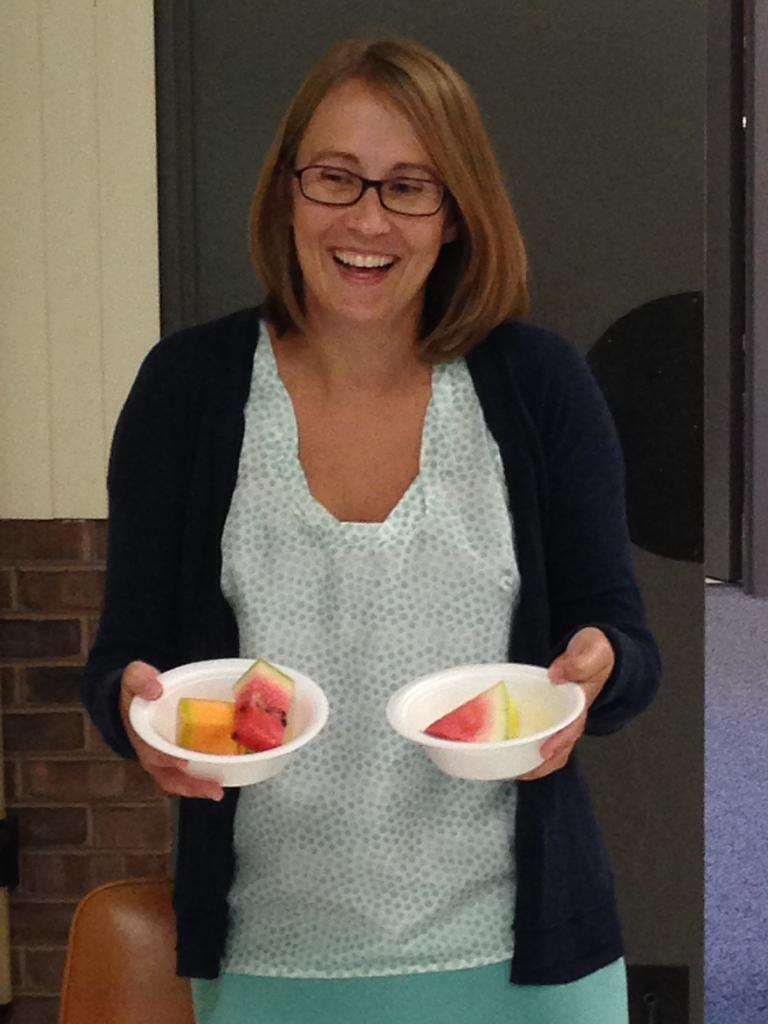Who is present in the image? There is a woman in the image. What is the woman holding in the image? The woman is holding two bowls in the image. What is in the bowls that the woman is holding? The bowls contain fruits. What is the woman's facial expression in the image? The woman is smiling in the image. What accessory is the woman wearing in the image? The woman is wearing spectacles in the image. What can be seen in the background of the image? There is a wall in the background of the image. Can you see any mint leaves in the image? There is no mention of mint leaves in the image, so it cannot be determined if they are present. 